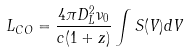<formula> <loc_0><loc_0><loc_500><loc_500>L _ { C O } = \frac { 4 \pi D _ { L } ^ { 2 } \nu _ { 0 } } { c ( 1 + z ) } \int S ( V ) d V</formula> 